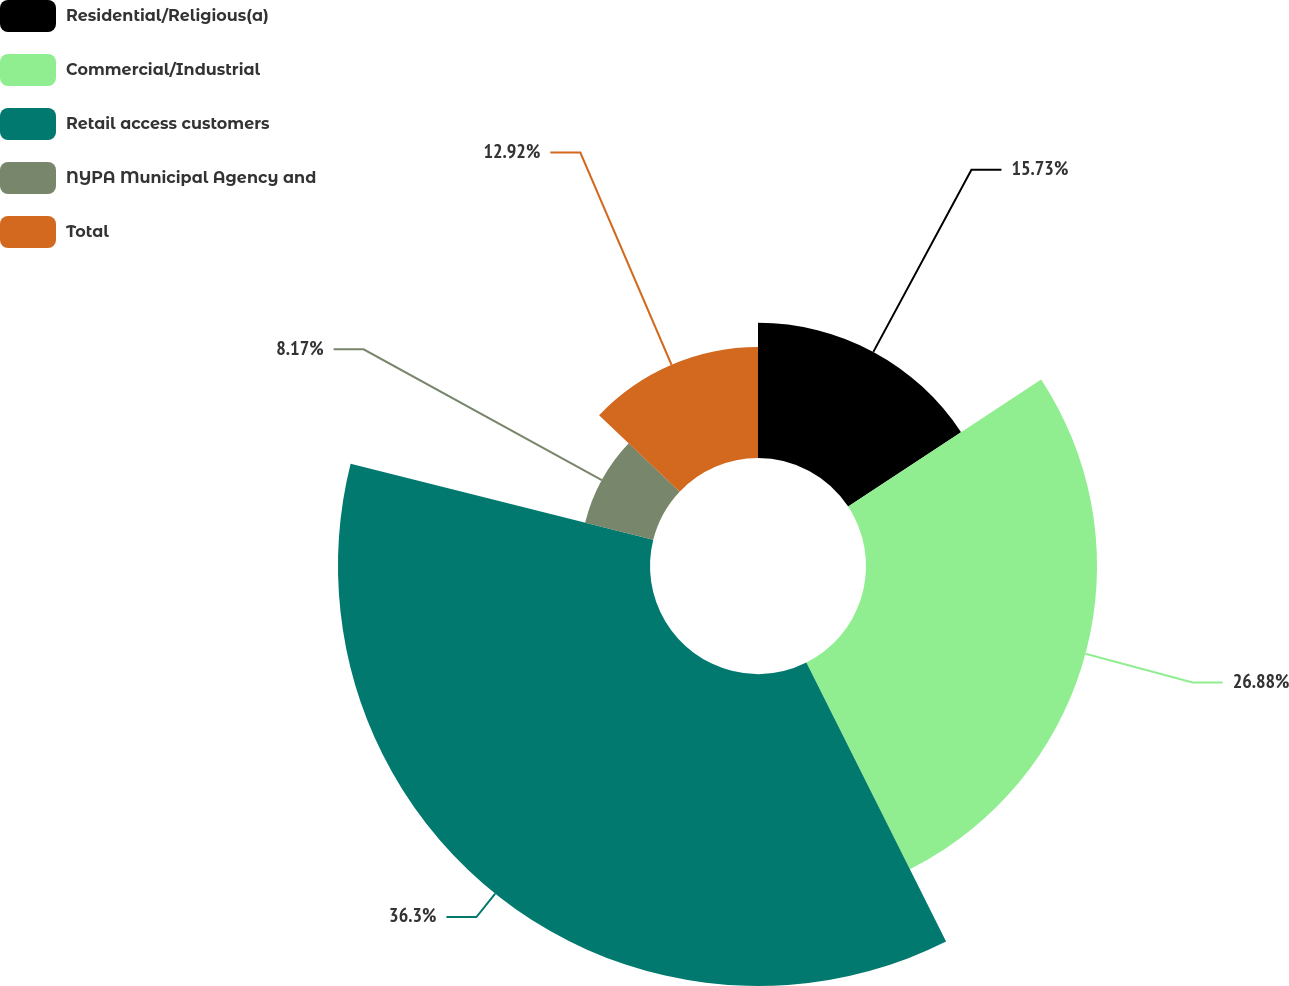<chart> <loc_0><loc_0><loc_500><loc_500><pie_chart><fcel>Residential/Religious(a)<fcel>Commercial/Industrial<fcel>Retail access customers<fcel>NYPA Municipal Agency and<fcel>Total<nl><fcel>15.73%<fcel>26.88%<fcel>36.3%<fcel>8.17%<fcel>12.92%<nl></chart> 